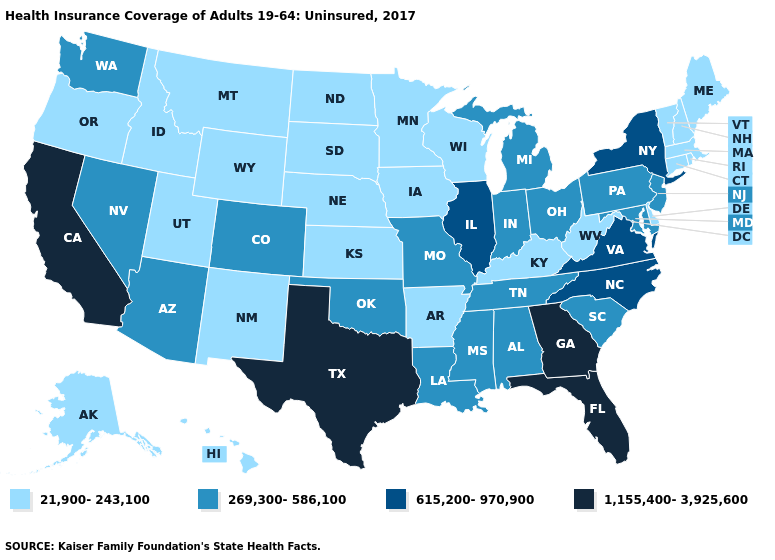What is the lowest value in states that border Oregon?
Concise answer only. 21,900-243,100. Is the legend a continuous bar?
Quick response, please. No. What is the highest value in states that border Mississippi?
Answer briefly. 269,300-586,100. Does Maine have a lower value than Iowa?
Give a very brief answer. No. Name the states that have a value in the range 269,300-586,100?
Keep it brief. Alabama, Arizona, Colorado, Indiana, Louisiana, Maryland, Michigan, Mississippi, Missouri, Nevada, New Jersey, Ohio, Oklahoma, Pennsylvania, South Carolina, Tennessee, Washington. What is the value of Pennsylvania?
Answer briefly. 269,300-586,100. Name the states that have a value in the range 269,300-586,100?
Give a very brief answer. Alabama, Arizona, Colorado, Indiana, Louisiana, Maryland, Michigan, Mississippi, Missouri, Nevada, New Jersey, Ohio, Oklahoma, Pennsylvania, South Carolina, Tennessee, Washington. What is the value of North Carolina?
Keep it brief. 615,200-970,900. What is the highest value in the MidWest ?
Keep it brief. 615,200-970,900. What is the value of Connecticut?
Short answer required. 21,900-243,100. Name the states that have a value in the range 615,200-970,900?
Answer briefly. Illinois, New York, North Carolina, Virginia. How many symbols are there in the legend?
Concise answer only. 4. Does Georgia have the highest value in the South?
Quick response, please. Yes. Does the first symbol in the legend represent the smallest category?
Give a very brief answer. Yes. Does Georgia have the highest value in the USA?
Write a very short answer. Yes. 